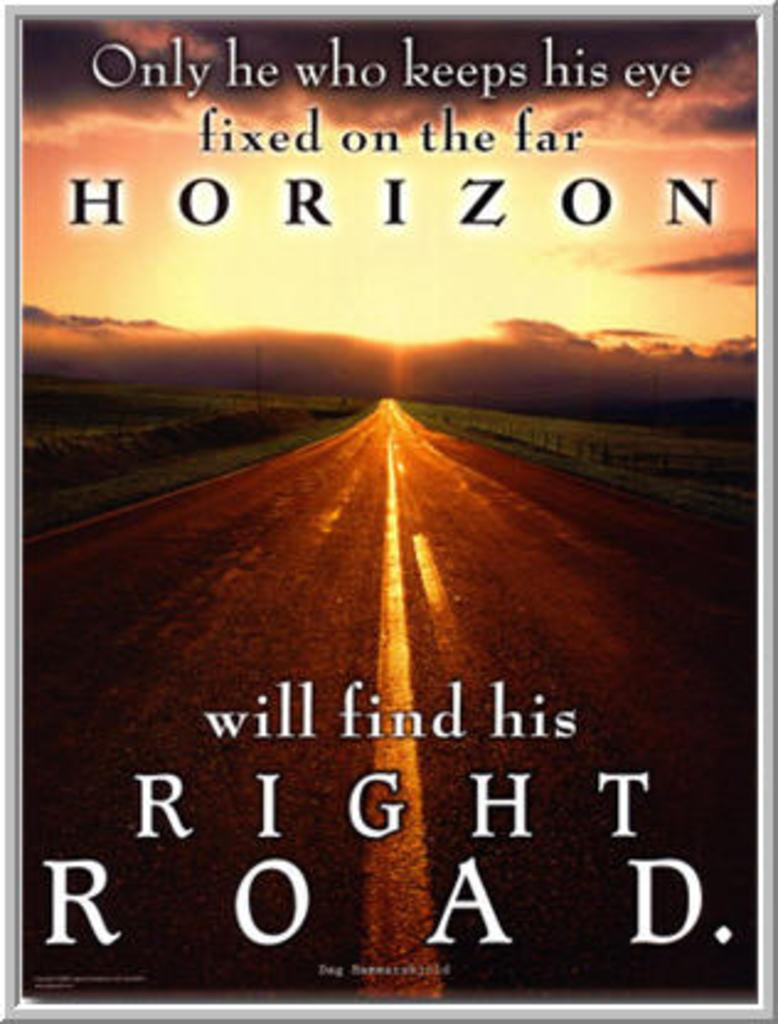Provide a one-sentence caption for the provided image. A book cover has the word horizon in large print towards the top. 